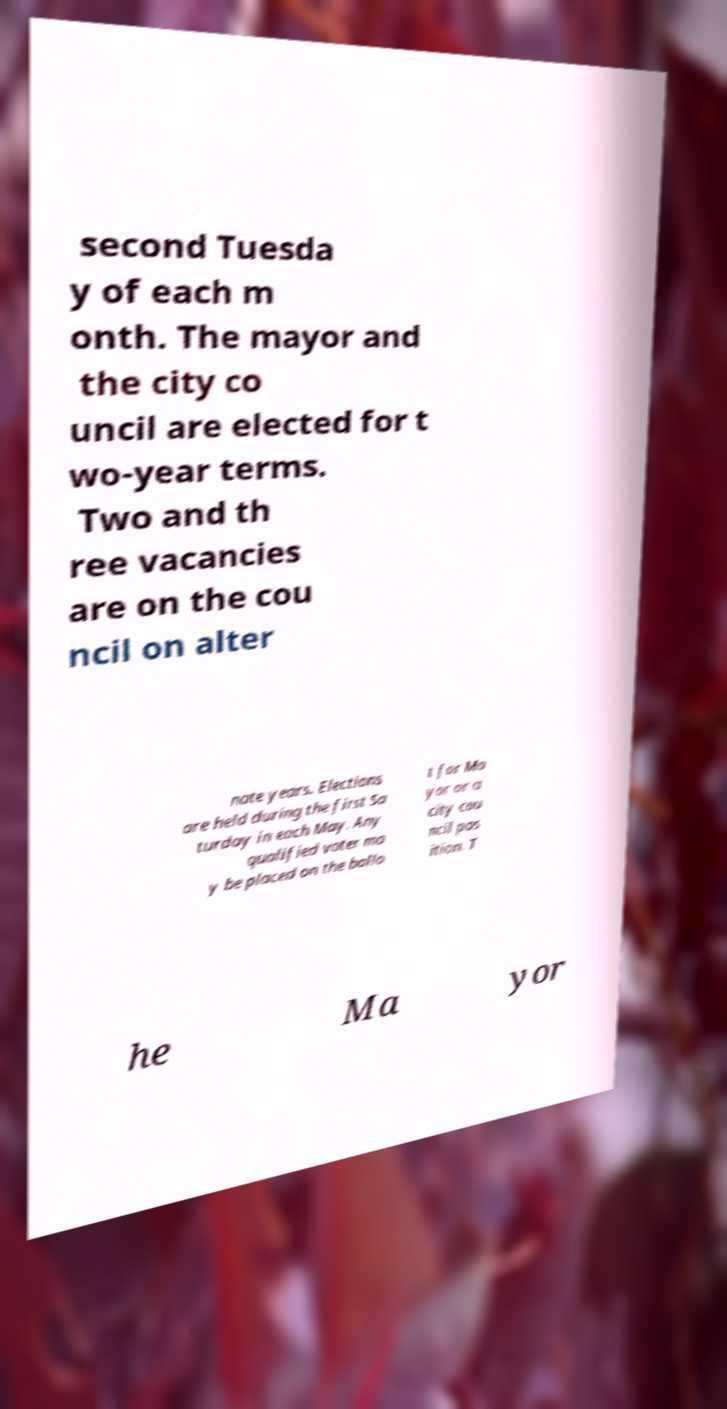Please read and relay the text visible in this image. What does it say? second Tuesda y of each m onth. The mayor and the city co uncil are elected for t wo-year terms. Two and th ree vacancies are on the cou ncil on alter nate years. Elections are held during the first Sa turday in each May. Any qualified voter ma y be placed on the ballo t for Ma yor or a city cou ncil pos ition. T he Ma yor 